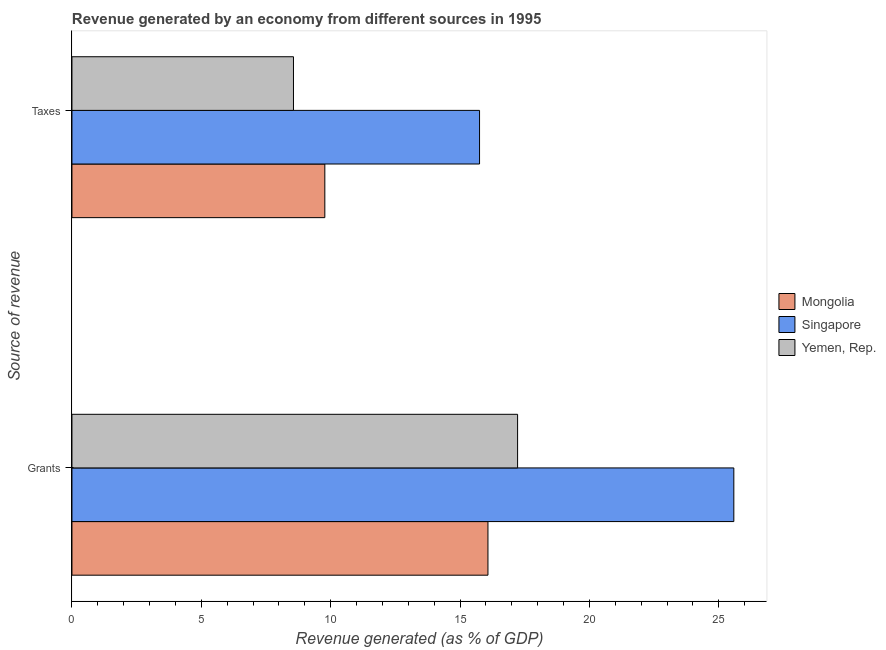How many different coloured bars are there?
Make the answer very short. 3. Are the number of bars per tick equal to the number of legend labels?
Offer a terse response. Yes. How many bars are there on the 2nd tick from the top?
Offer a very short reply. 3. How many bars are there on the 2nd tick from the bottom?
Give a very brief answer. 3. What is the label of the 1st group of bars from the top?
Provide a short and direct response. Taxes. What is the revenue generated by taxes in Singapore?
Provide a succinct answer. 15.75. Across all countries, what is the maximum revenue generated by taxes?
Keep it short and to the point. 15.75. Across all countries, what is the minimum revenue generated by grants?
Offer a very short reply. 16.08. In which country was the revenue generated by taxes maximum?
Give a very brief answer. Singapore. In which country was the revenue generated by taxes minimum?
Provide a short and direct response. Yemen, Rep. What is the total revenue generated by grants in the graph?
Make the answer very short. 58.89. What is the difference between the revenue generated by taxes in Singapore and that in Yemen, Rep.?
Provide a short and direct response. 7.19. What is the difference between the revenue generated by taxes in Mongolia and the revenue generated by grants in Singapore?
Offer a terse response. -15.81. What is the average revenue generated by grants per country?
Your response must be concise. 19.63. What is the difference between the revenue generated by grants and revenue generated by taxes in Singapore?
Give a very brief answer. 9.83. In how many countries, is the revenue generated by taxes greater than 4 %?
Keep it short and to the point. 3. What is the ratio of the revenue generated by taxes in Yemen, Rep. to that in Singapore?
Ensure brevity in your answer.  0.54. Is the revenue generated by taxes in Yemen, Rep. less than that in Singapore?
Give a very brief answer. Yes. In how many countries, is the revenue generated by taxes greater than the average revenue generated by taxes taken over all countries?
Your response must be concise. 1. What does the 3rd bar from the top in Grants represents?
Your response must be concise. Mongolia. What does the 3rd bar from the bottom in Grants represents?
Ensure brevity in your answer.  Yemen, Rep. How many bars are there?
Your response must be concise. 6. How many countries are there in the graph?
Your answer should be compact. 3. What is the difference between two consecutive major ticks on the X-axis?
Your answer should be compact. 5. Does the graph contain grids?
Your answer should be compact. No. How many legend labels are there?
Ensure brevity in your answer.  3. What is the title of the graph?
Offer a terse response. Revenue generated by an economy from different sources in 1995. What is the label or title of the X-axis?
Offer a terse response. Revenue generated (as % of GDP). What is the label or title of the Y-axis?
Make the answer very short. Source of revenue. What is the Revenue generated (as % of GDP) of Mongolia in Grants?
Your response must be concise. 16.08. What is the Revenue generated (as % of GDP) in Singapore in Grants?
Ensure brevity in your answer.  25.58. What is the Revenue generated (as % of GDP) of Yemen, Rep. in Grants?
Your response must be concise. 17.22. What is the Revenue generated (as % of GDP) of Mongolia in Taxes?
Your response must be concise. 9.77. What is the Revenue generated (as % of GDP) in Singapore in Taxes?
Offer a terse response. 15.75. What is the Revenue generated (as % of GDP) of Yemen, Rep. in Taxes?
Offer a very short reply. 8.56. Across all Source of revenue, what is the maximum Revenue generated (as % of GDP) of Mongolia?
Make the answer very short. 16.08. Across all Source of revenue, what is the maximum Revenue generated (as % of GDP) in Singapore?
Offer a terse response. 25.58. Across all Source of revenue, what is the maximum Revenue generated (as % of GDP) of Yemen, Rep.?
Your answer should be very brief. 17.22. Across all Source of revenue, what is the minimum Revenue generated (as % of GDP) in Mongolia?
Ensure brevity in your answer.  9.77. Across all Source of revenue, what is the minimum Revenue generated (as % of GDP) of Singapore?
Ensure brevity in your answer.  15.75. Across all Source of revenue, what is the minimum Revenue generated (as % of GDP) of Yemen, Rep.?
Ensure brevity in your answer.  8.56. What is the total Revenue generated (as % of GDP) in Mongolia in the graph?
Your answer should be very brief. 25.85. What is the total Revenue generated (as % of GDP) in Singapore in the graph?
Provide a succinct answer. 41.34. What is the total Revenue generated (as % of GDP) of Yemen, Rep. in the graph?
Your answer should be compact. 25.79. What is the difference between the Revenue generated (as % of GDP) of Mongolia in Grants and that in Taxes?
Keep it short and to the point. 6.3. What is the difference between the Revenue generated (as % of GDP) in Singapore in Grants and that in Taxes?
Your response must be concise. 9.83. What is the difference between the Revenue generated (as % of GDP) in Yemen, Rep. in Grants and that in Taxes?
Keep it short and to the point. 8.66. What is the difference between the Revenue generated (as % of GDP) of Mongolia in Grants and the Revenue generated (as % of GDP) of Singapore in Taxes?
Your answer should be very brief. 0.32. What is the difference between the Revenue generated (as % of GDP) in Mongolia in Grants and the Revenue generated (as % of GDP) in Yemen, Rep. in Taxes?
Your response must be concise. 7.52. What is the difference between the Revenue generated (as % of GDP) of Singapore in Grants and the Revenue generated (as % of GDP) of Yemen, Rep. in Taxes?
Your response must be concise. 17.02. What is the average Revenue generated (as % of GDP) of Mongolia per Source of revenue?
Offer a very short reply. 12.93. What is the average Revenue generated (as % of GDP) in Singapore per Source of revenue?
Ensure brevity in your answer.  20.67. What is the average Revenue generated (as % of GDP) in Yemen, Rep. per Source of revenue?
Your answer should be very brief. 12.89. What is the difference between the Revenue generated (as % of GDP) in Mongolia and Revenue generated (as % of GDP) in Singapore in Grants?
Your answer should be very brief. -9.5. What is the difference between the Revenue generated (as % of GDP) of Mongolia and Revenue generated (as % of GDP) of Yemen, Rep. in Grants?
Keep it short and to the point. -1.15. What is the difference between the Revenue generated (as % of GDP) of Singapore and Revenue generated (as % of GDP) of Yemen, Rep. in Grants?
Keep it short and to the point. 8.36. What is the difference between the Revenue generated (as % of GDP) of Mongolia and Revenue generated (as % of GDP) of Singapore in Taxes?
Make the answer very short. -5.98. What is the difference between the Revenue generated (as % of GDP) of Mongolia and Revenue generated (as % of GDP) of Yemen, Rep. in Taxes?
Keep it short and to the point. 1.21. What is the difference between the Revenue generated (as % of GDP) in Singapore and Revenue generated (as % of GDP) in Yemen, Rep. in Taxes?
Your answer should be very brief. 7.19. What is the ratio of the Revenue generated (as % of GDP) of Mongolia in Grants to that in Taxes?
Provide a short and direct response. 1.65. What is the ratio of the Revenue generated (as % of GDP) in Singapore in Grants to that in Taxes?
Your answer should be very brief. 1.62. What is the ratio of the Revenue generated (as % of GDP) of Yemen, Rep. in Grants to that in Taxes?
Keep it short and to the point. 2.01. What is the difference between the highest and the second highest Revenue generated (as % of GDP) of Mongolia?
Your answer should be very brief. 6.3. What is the difference between the highest and the second highest Revenue generated (as % of GDP) in Singapore?
Provide a short and direct response. 9.83. What is the difference between the highest and the second highest Revenue generated (as % of GDP) in Yemen, Rep.?
Give a very brief answer. 8.66. What is the difference between the highest and the lowest Revenue generated (as % of GDP) in Mongolia?
Provide a short and direct response. 6.3. What is the difference between the highest and the lowest Revenue generated (as % of GDP) in Singapore?
Keep it short and to the point. 9.83. What is the difference between the highest and the lowest Revenue generated (as % of GDP) of Yemen, Rep.?
Offer a terse response. 8.66. 